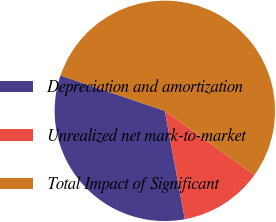<chart> <loc_0><loc_0><loc_500><loc_500><pie_chart><fcel>Depreciation and amortization<fcel>Unrealized net mark-to-market<fcel>Total Impact of Significant<nl><fcel>33.11%<fcel>12.21%<fcel>54.68%<nl></chart> 